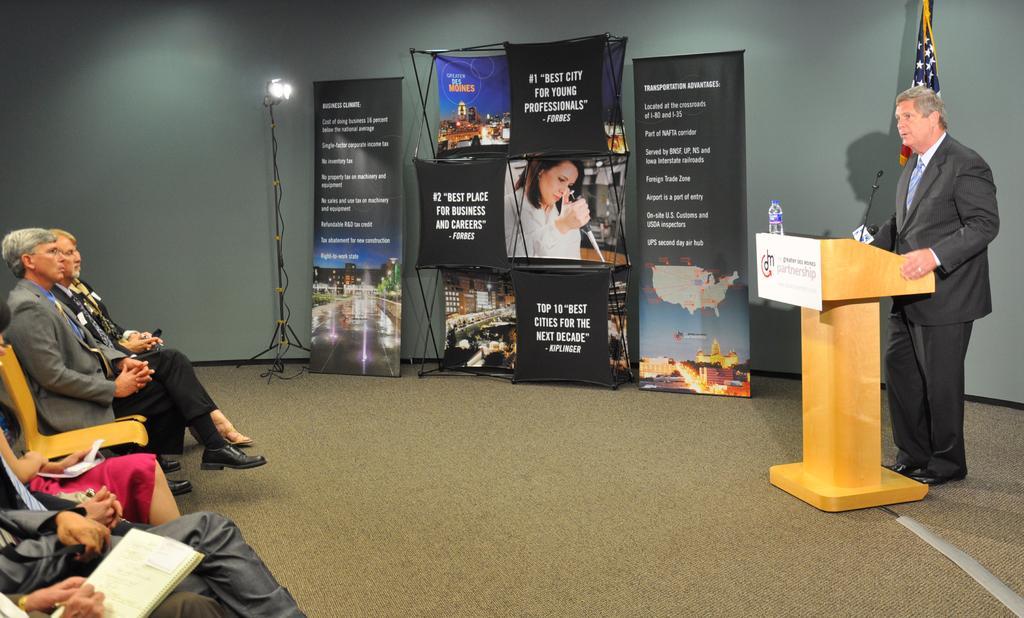Please provide a concise description of this image. On the right side of the image, we can see a man is standing. He is wearing a suit. In front of the man, we can see a podium, bottle and mic. In the background, we can see banners, stand, light, flag and the wall. On the left side of the image, we can see people are sitting on the chairs. We can see a person is holding a pen and writing in a book in the left bottom of the image. On the floor, we can see the carpet. 